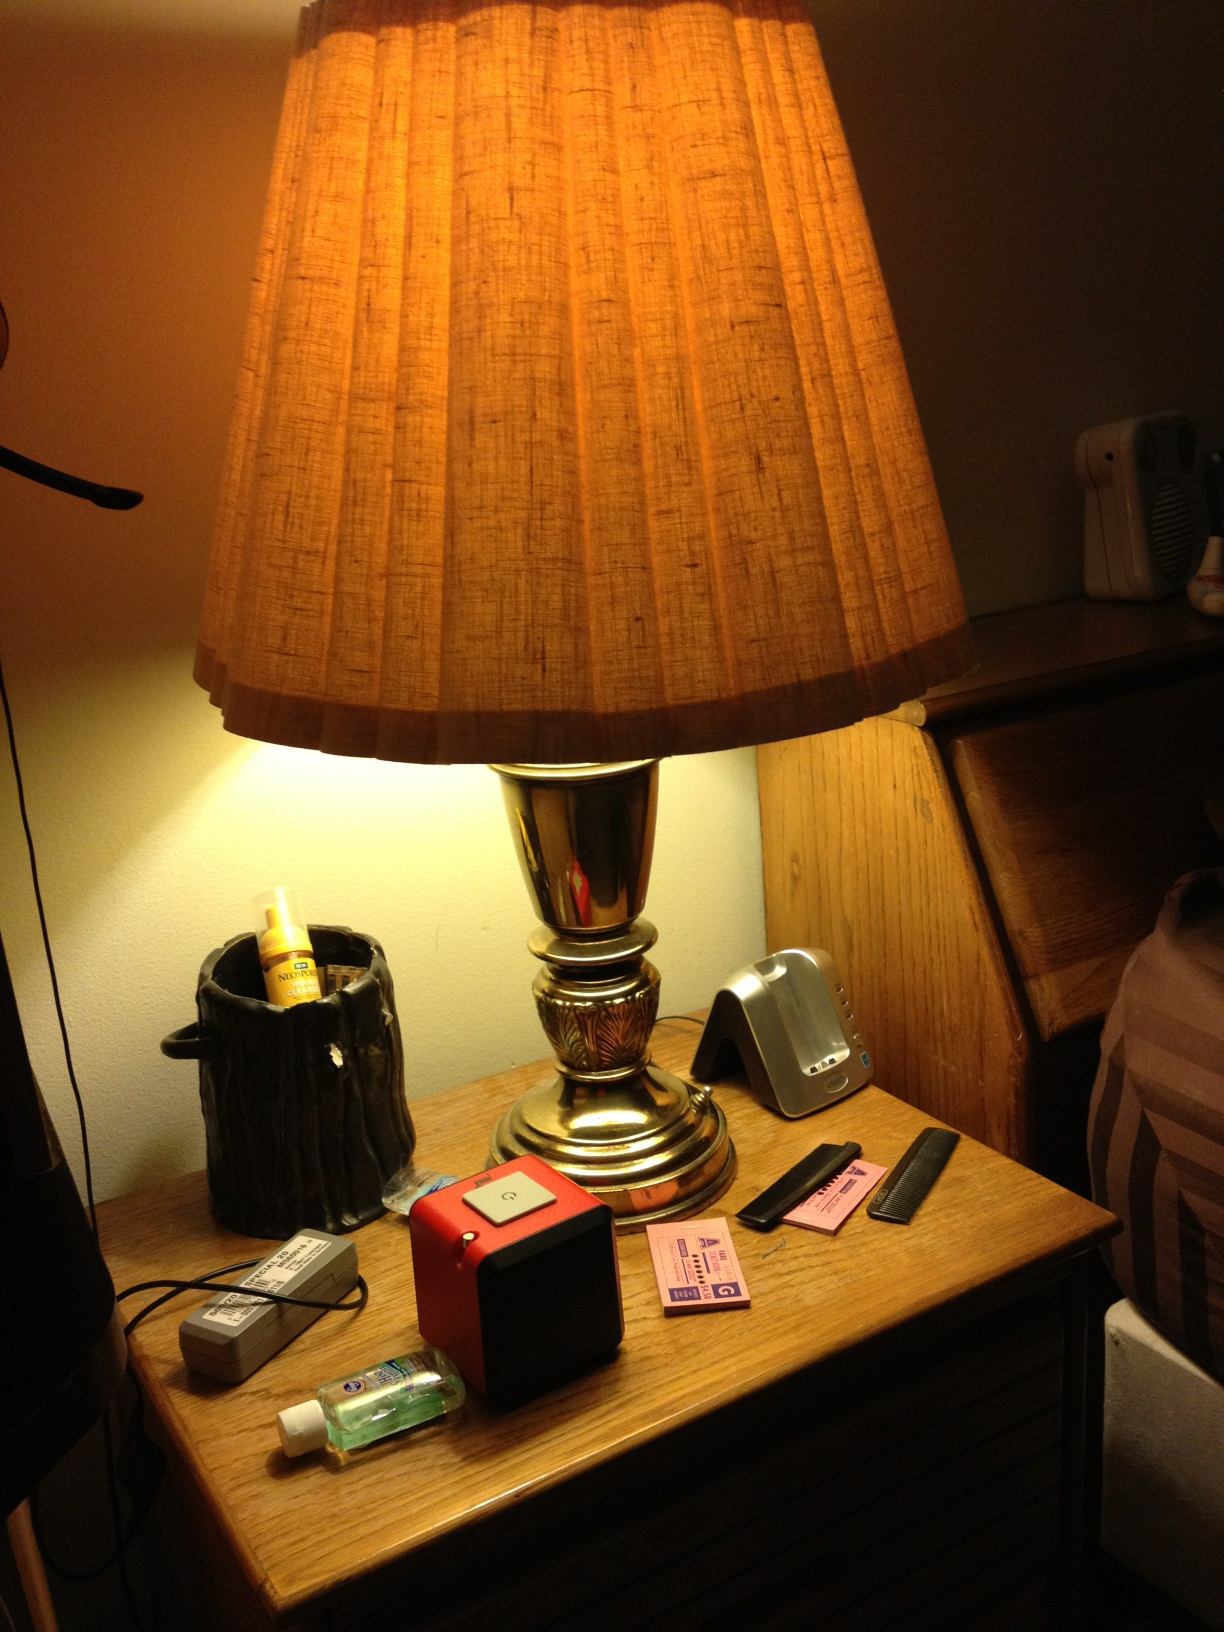Is this light on? Yes, the light on the lamp is currently on. The illumination of the lamp shade and the surrounding objects on the table clearly indicate that the light is switched on. 